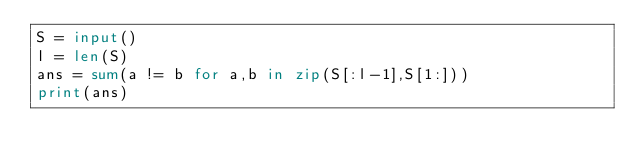<code> <loc_0><loc_0><loc_500><loc_500><_Python_>S = input()
l = len(S)
ans = sum(a != b for a,b in zip(S[:l-1],S[1:]))
print(ans)</code> 